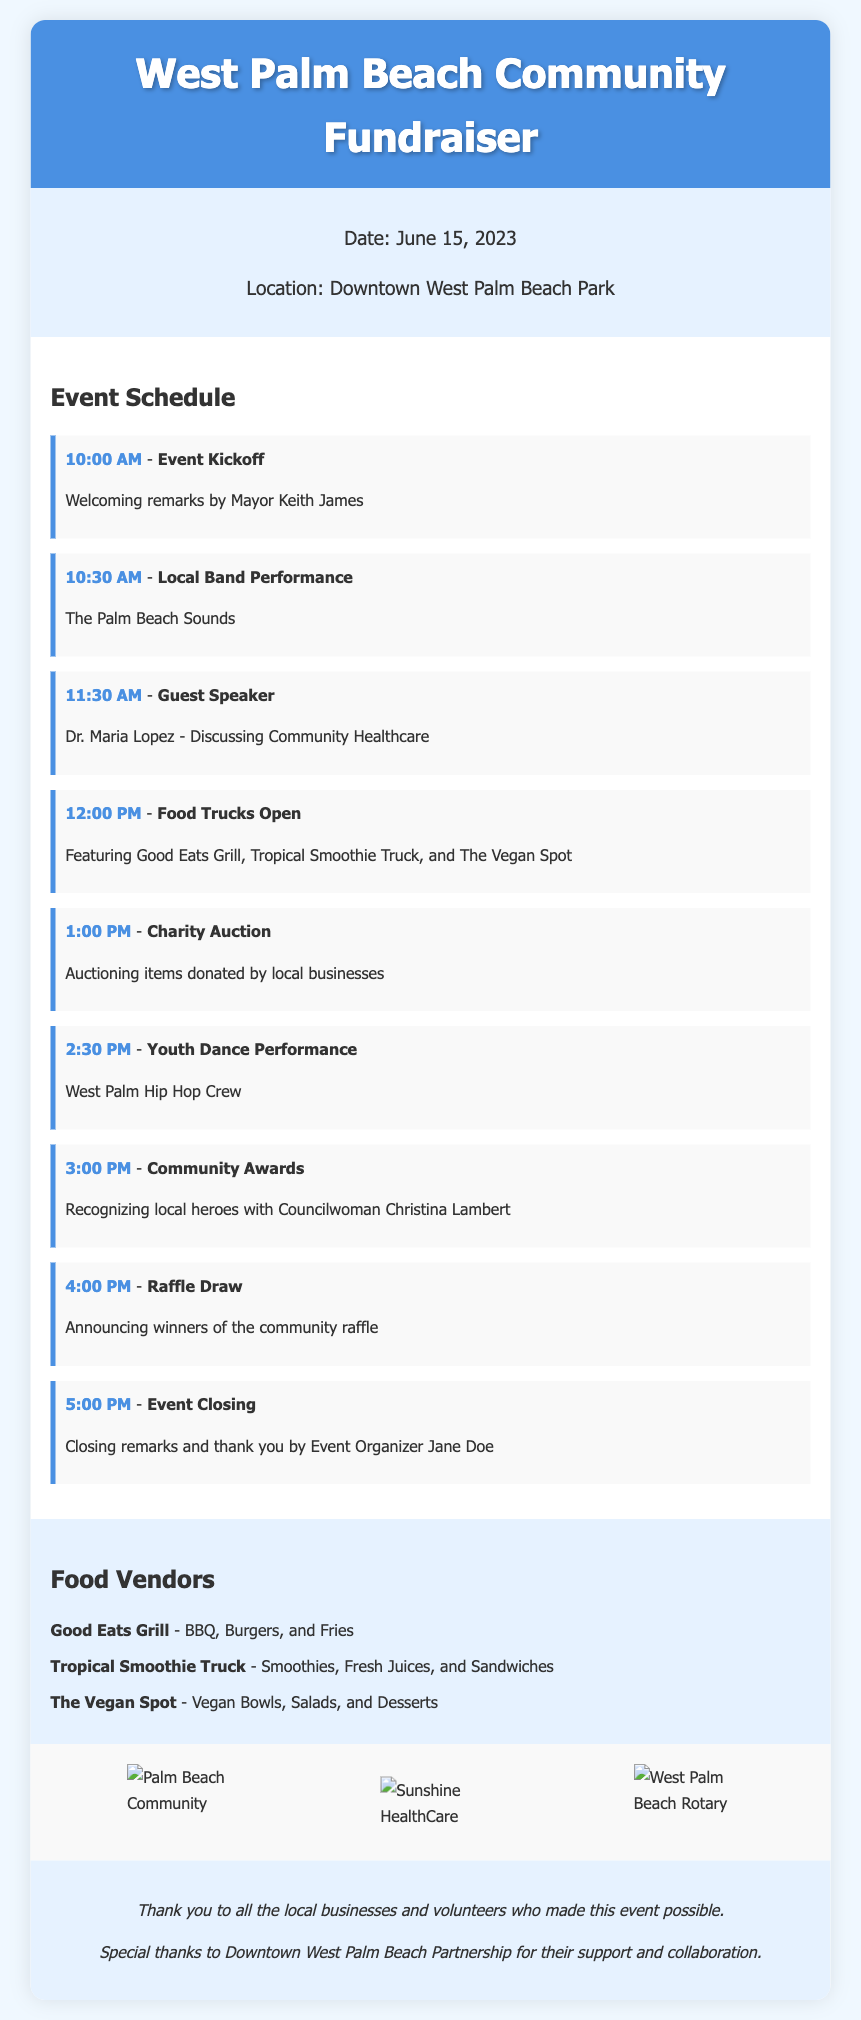what is the date of the event? The date is specified in the event details section of the document.
Answer: June 15, 2023 what time does the event kick off? The kickoff time is mentioned as part of the event schedule.
Answer: 10:00 AM who is the guest speaker? The schedule mentions the name of the guest speaker during the event.
Answer: Dr. Maria Lopez what type of cuisine does The Vegan Spot offer? The food vendor section specifies the type of offerings for each vendor.
Answer: Vegan Bowls, Salads, and Desserts how many food vendors are featured in the event? The food vendors section lists each vendor individually, allowing for a count.
Answer: 3 what will happen at 1:00 PM? The event schedule outlines activities happening at specific times, including this one.
Answer: Charity Auction who is giving the closing remarks? The document identifies the person responsible for closing remarks in the event schedule.
Answer: Jane Doe what is the location of the fundraiser? The event details section explicitly states the location.
Answer: Downtown West Palm Beach Park how many sponsors are featured in the document? The sponsors section presents logos which can be counted to determine the total number.
Answer: 3 